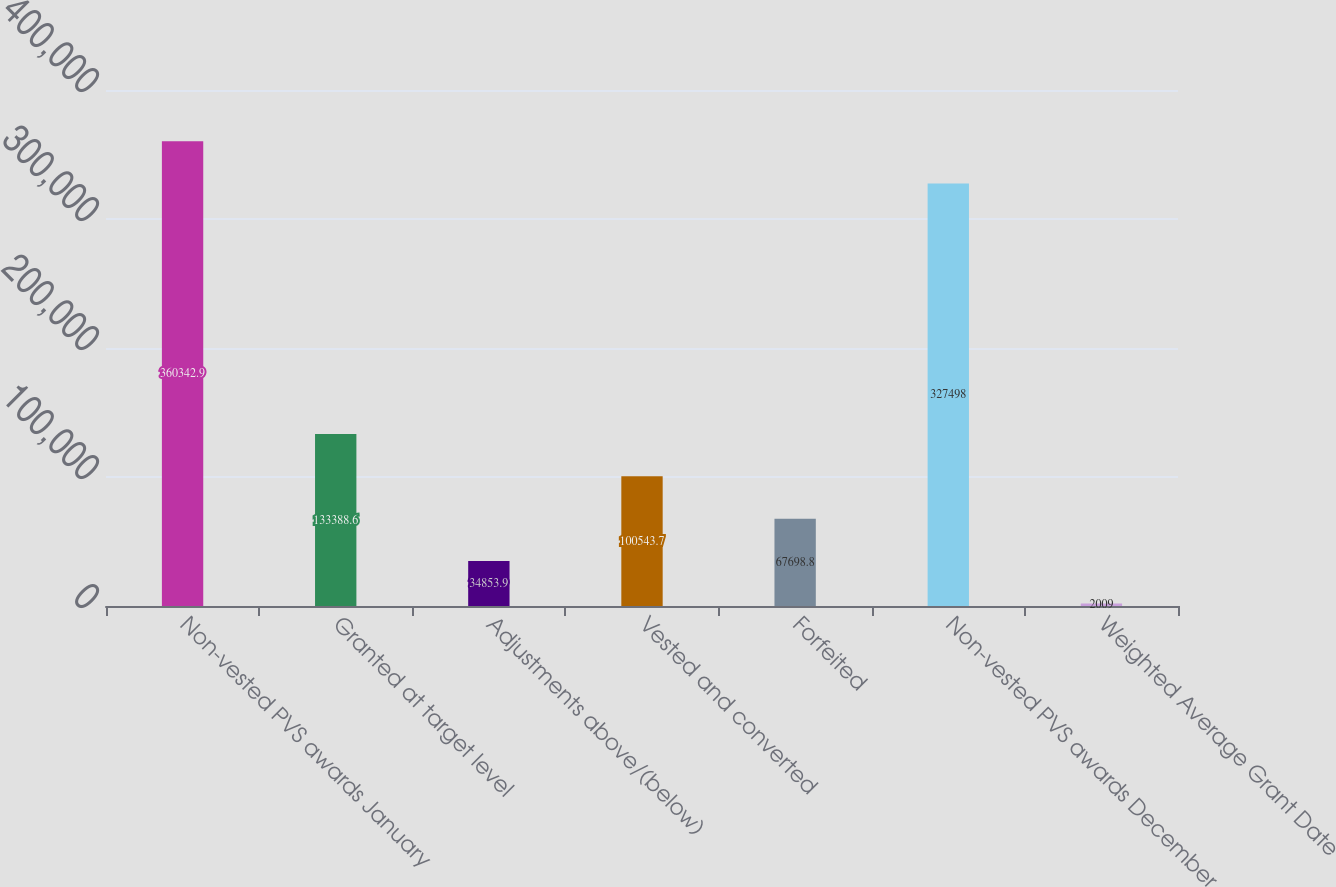Convert chart to OTSL. <chart><loc_0><loc_0><loc_500><loc_500><bar_chart><fcel>Non-vested PVS awards January<fcel>Granted at target level<fcel>Adjustments above/(below)<fcel>Vested and converted<fcel>Forfeited<fcel>Non-vested PVS awards December<fcel>Weighted Average Grant Date<nl><fcel>360343<fcel>133389<fcel>34853.9<fcel>100544<fcel>67698.8<fcel>327498<fcel>2009<nl></chart> 